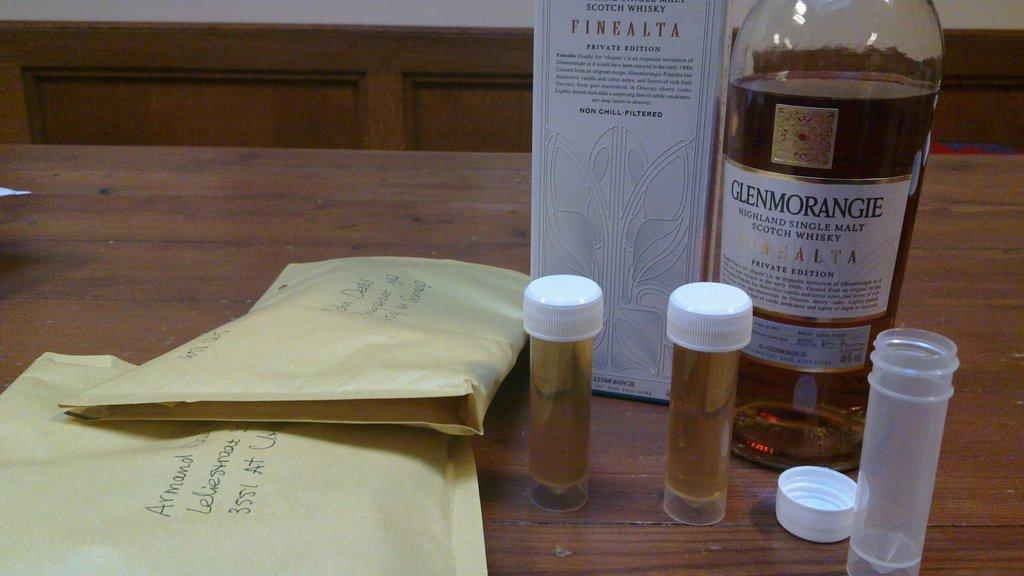<image>
Present a compact description of the photo's key features. A bottle of Glenmorangie single malt scotch whisky is on a table along with several vials and two envelopes. 